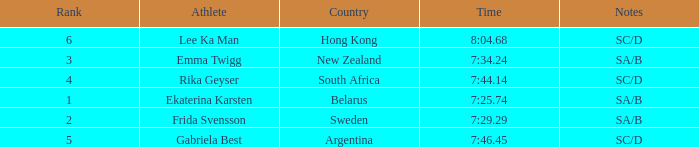What is the time of frida svensson's race that had sa/b under the notes? 7:29.29. Could you help me parse every detail presented in this table? {'header': ['Rank', 'Athlete', 'Country', 'Time', 'Notes'], 'rows': [['6', 'Lee Ka Man', 'Hong Kong', '8:04.68', 'SC/D'], ['3', 'Emma Twigg', 'New Zealand', '7:34.24', 'SA/B'], ['4', 'Rika Geyser', 'South Africa', '7:44.14', 'SC/D'], ['1', 'Ekaterina Karsten', 'Belarus', '7:25.74', 'SA/B'], ['2', 'Frida Svensson', 'Sweden', '7:29.29', 'SA/B'], ['5', 'Gabriela Best', 'Argentina', '7:46.45', 'SC/D']]} 